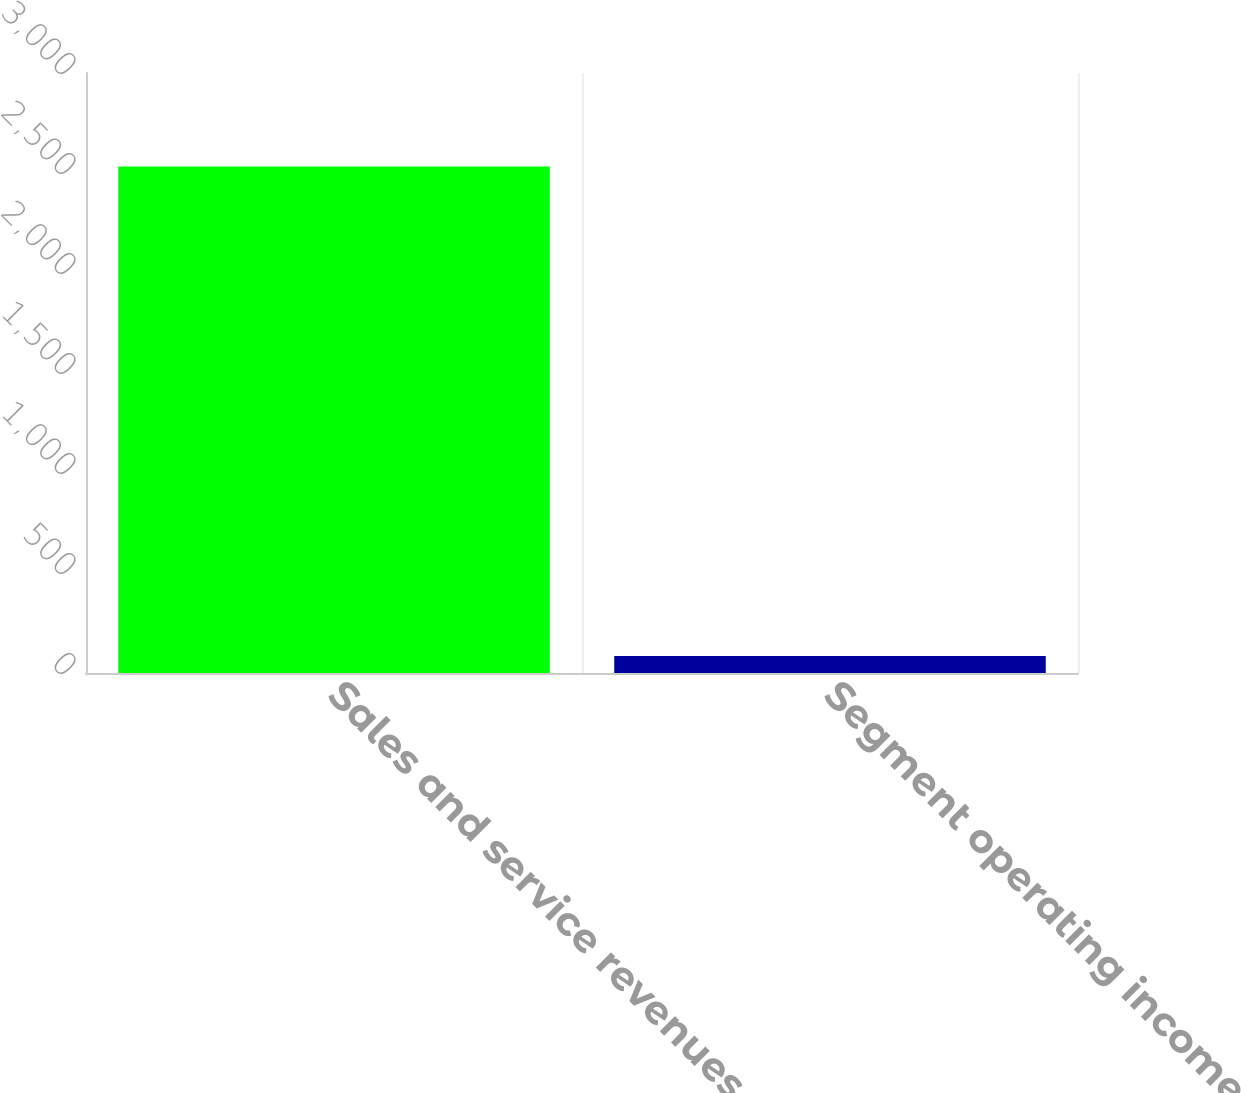Convert chart. <chart><loc_0><loc_0><loc_500><loc_500><bar_chart><fcel>Sales and service revenues<fcel>Segment operating income<nl><fcel>2532<fcel>85<nl></chart> 